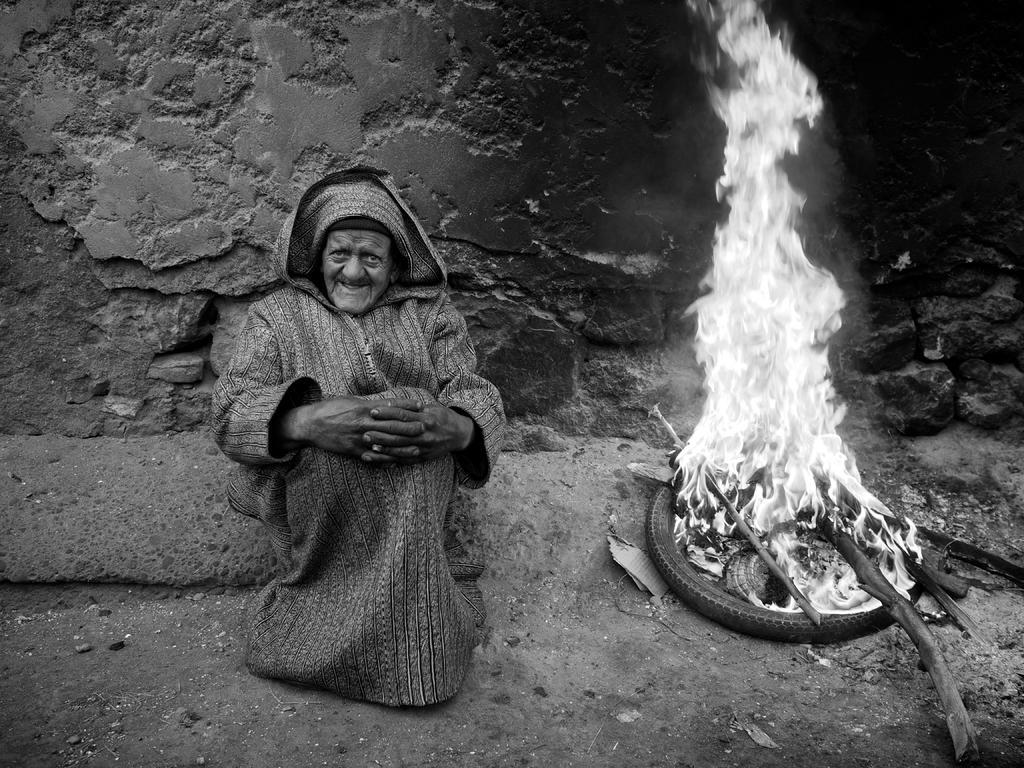Describe this image in one or two sentences. This picture is clicked outside. On the right there is a bonfire on the ground. On the left there is a person wearing a long jacket and seems to be sitting on the ground. In the background there is a wall. 